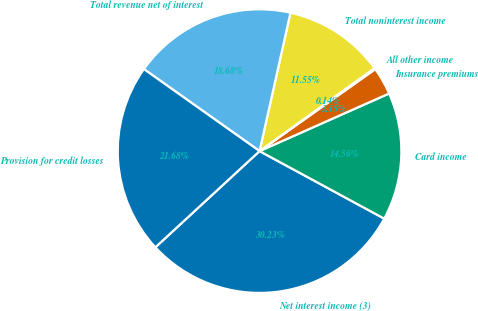Convert chart. <chart><loc_0><loc_0><loc_500><loc_500><pie_chart><fcel>Net interest income (3)<fcel>Card income<fcel>Insurance premiums<fcel>All other income<fcel>Total noninterest income<fcel>Total revenue net of interest<fcel>Provision for credit losses<nl><fcel>30.23%<fcel>14.56%<fcel>3.15%<fcel>0.14%<fcel>11.55%<fcel>18.68%<fcel>21.68%<nl></chart> 